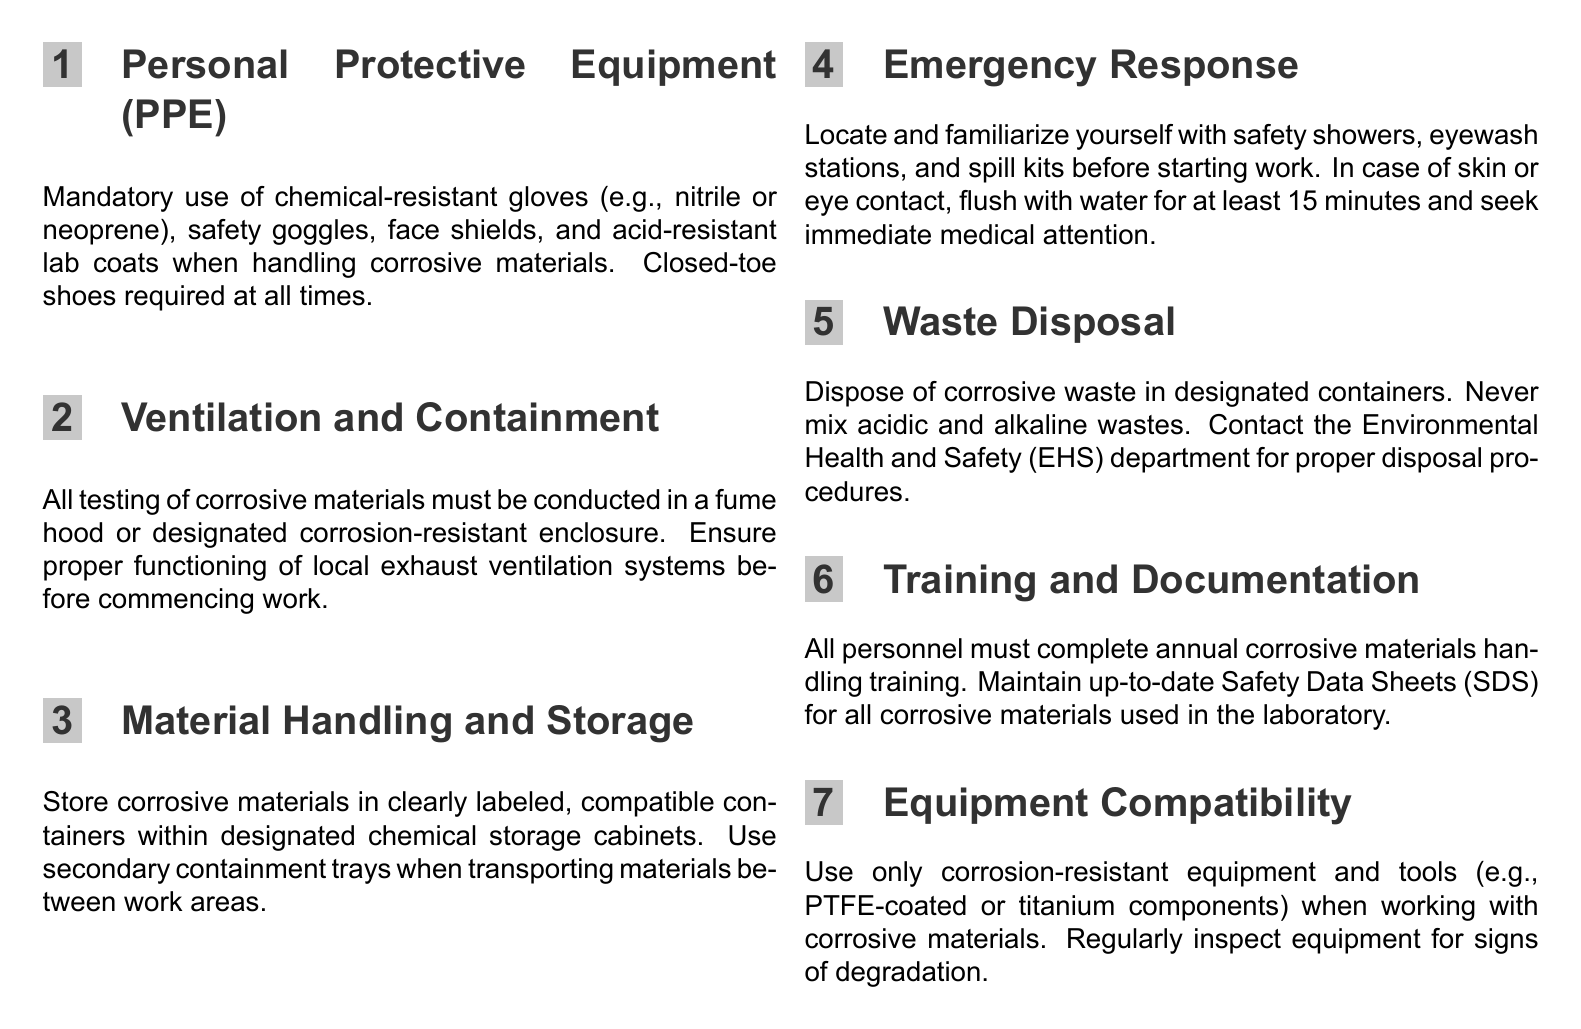What type of gloves are mandatory? The document specifies the mandatory use of chemical-resistant gloves, mentioning examples such as nitrile or neoprene.
Answer: nitrile or neoprene Where must corrosive material testing be conducted? The document states that all testing of corrosive materials must be conducted in a fume hood or designated corrosion-resistant enclosure.
Answer: fume hood or designated corrosion-resistant enclosure What is the minimum flushing time for eye contact? In the emergency response section, it is documented that in case of eye contact, one should flush with water for at least 15 minutes.
Answer: 15 minutes Which department should be contacted for waste disposal procedures? The document indicates that personnel should contact the Environmental Health and Safety (EHS) department for proper disposal procedures.
Answer: Environmental Health and Safety (EHS) What type of training must personnel complete annually? According to the training and documentation section, all personnel must complete annual corrosive materials handling training.
Answer: annual corrosive materials handling training What should be used when transporting corrosive materials? The material handling and storage section specifies the use of secondary containment trays when transporting materials between work areas.
Answer: secondary containment trays What kind of equipment is required for handling corrosive materials? The equipment compatibility section mandates the use of corrosion-resistant equipment and tools.
Answer: corrosion-resistant equipment and tools What should be familiarized with before starting work? The document mentions that personnel should locate and familiarize themselves with safety showers, eyewash stations, and spill kits before starting work.
Answer: safety showers, eyewash stations, and spill kits What should be done if corrosive waste is generated? The waste disposal section specifies disposing of corrosive waste in designated containers and never mixing acidic and alkaline wastes.
Answer: dispose in designated containers 